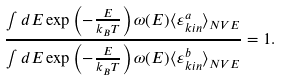<formula> <loc_0><loc_0><loc_500><loc_500>\frac { \int d E \exp \left ( - \frac { E } { k _ { B } T } \right ) \omega ( E ) \langle \varepsilon _ { k i n } ^ { a } \rangle _ { N V E } } { \int d E \exp \left ( - \frac { E } { k _ { B } T } \right ) \omega ( E ) \langle \varepsilon _ { k i n } ^ { b } \rangle _ { N V E } } = 1 .</formula> 